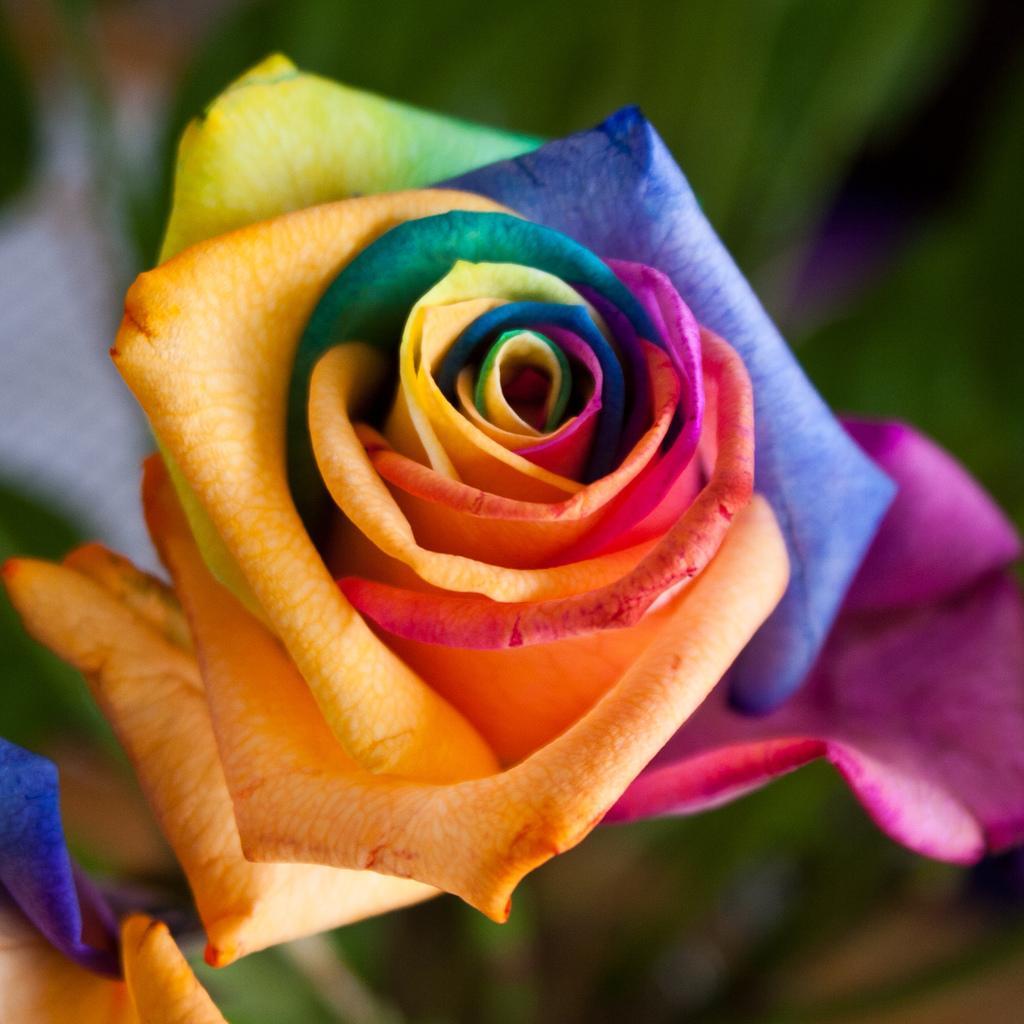Please provide a concise description of this image. In this image I can see a colorful flower and the blurry background. 